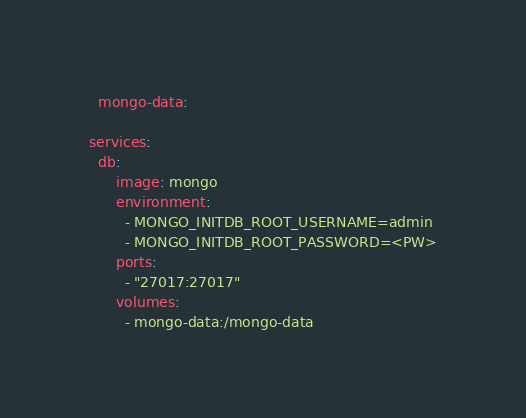<code> <loc_0><loc_0><loc_500><loc_500><_YAML_>  mongo-data:

services:
  db:
      image: mongo
      environment:
        - MONGO_INITDB_ROOT_USERNAME=admin
        - MONGO_INITDB_ROOT_PASSWORD=<PW>
      ports:
        - "27017:27017"
      volumes:
        - mongo-data:/mongo-data</code> 